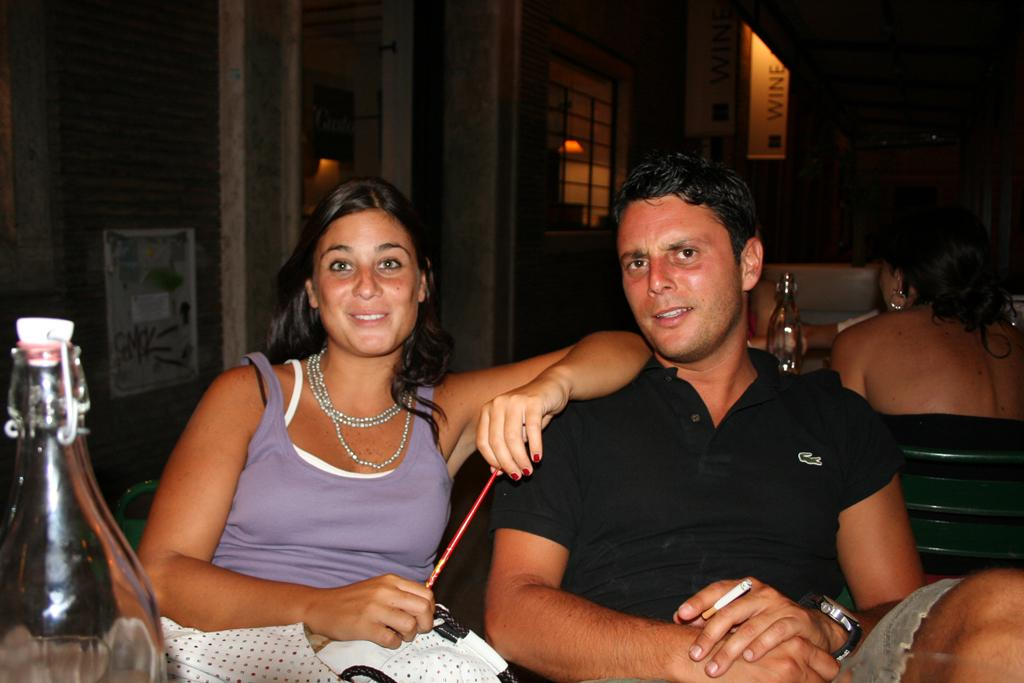What are the people in the image doing? The people in the image are sitting on chairs. Can you describe the setting in the image? There are other people sitting in the background of the image. How many giants can be seen in the image? There are no giants present in the image. What type of animal is sitting next to the people in the image? There is no animal, such as a donkey, present in the image. 